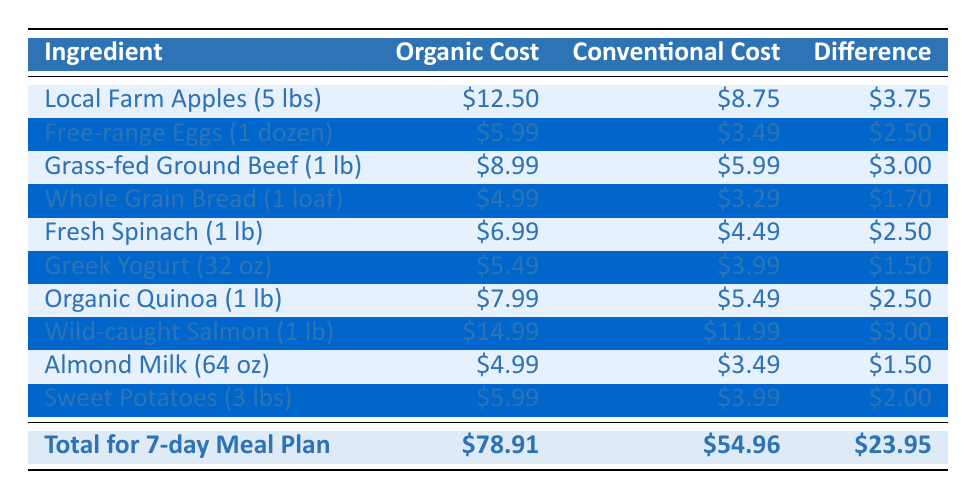What is the cost difference between Local Farm Apples and Free-range Eggs? The cost of Local Farm Apples is $12.50 and for Free-range Eggs it is $5.99. The difference is calculated by subtracting the cost of Free-range Eggs from the cost of Local Farm Apples: $12.50 - $5.99 = $6.51.
Answer: $6.51 Which ingredient has the highest organic cost? By examining the 'Organic Cost' column, we see that Wild-caught Salmon costs $14.99, which is higher than the costs of all other ingredients.
Answer: Wild-caught Salmon What is the total cost for the Conventional ingredients? To find the total for Conventional ingredients, we sum up all the values in the 'Conventional Cost' column: $8.75 + $3.49 + $5.99 + $3.29 + $4.49 + $3.99 + $5.49 + $11.99 + $3.49 + $3.99 = $54.96.
Answer: $54.96 Are Grass-fed Ground Beef and Wild-caught Salmon both more expensive in their organic forms compared to their conventional counterparts? Grass-fed Ground Beef costs $8.99 organic and $5.99 conventional, which shows a difference of $3.00, so it is more expensive in organic form. Wild-caught Salmon costs $14.99 organic and $11.99 conventional with a difference of $3.00, so it is also more expensive in organic form. Therefore, both are more expensive.
Answer: Yes What is the average cost difference of all the ingredients listed? To calculate the average cost difference, first sum the differences from the 'Difference' column: $3.75 + $2.50 + $3.00 + $1.70 + $2.50 + $1.50 + $2.50 + $3.00 + $1.50 + $2.00 = $23.95. Since there are 10 ingredients, divide this total by 10: $23.95 / 10 = $2.395.
Answer: $2.395 